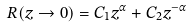Convert formula to latex. <formula><loc_0><loc_0><loc_500><loc_500>R ( z \rightarrow 0 ) = C _ { 1 } z ^ { \alpha } + C _ { 2 } z ^ { - \alpha }</formula> 